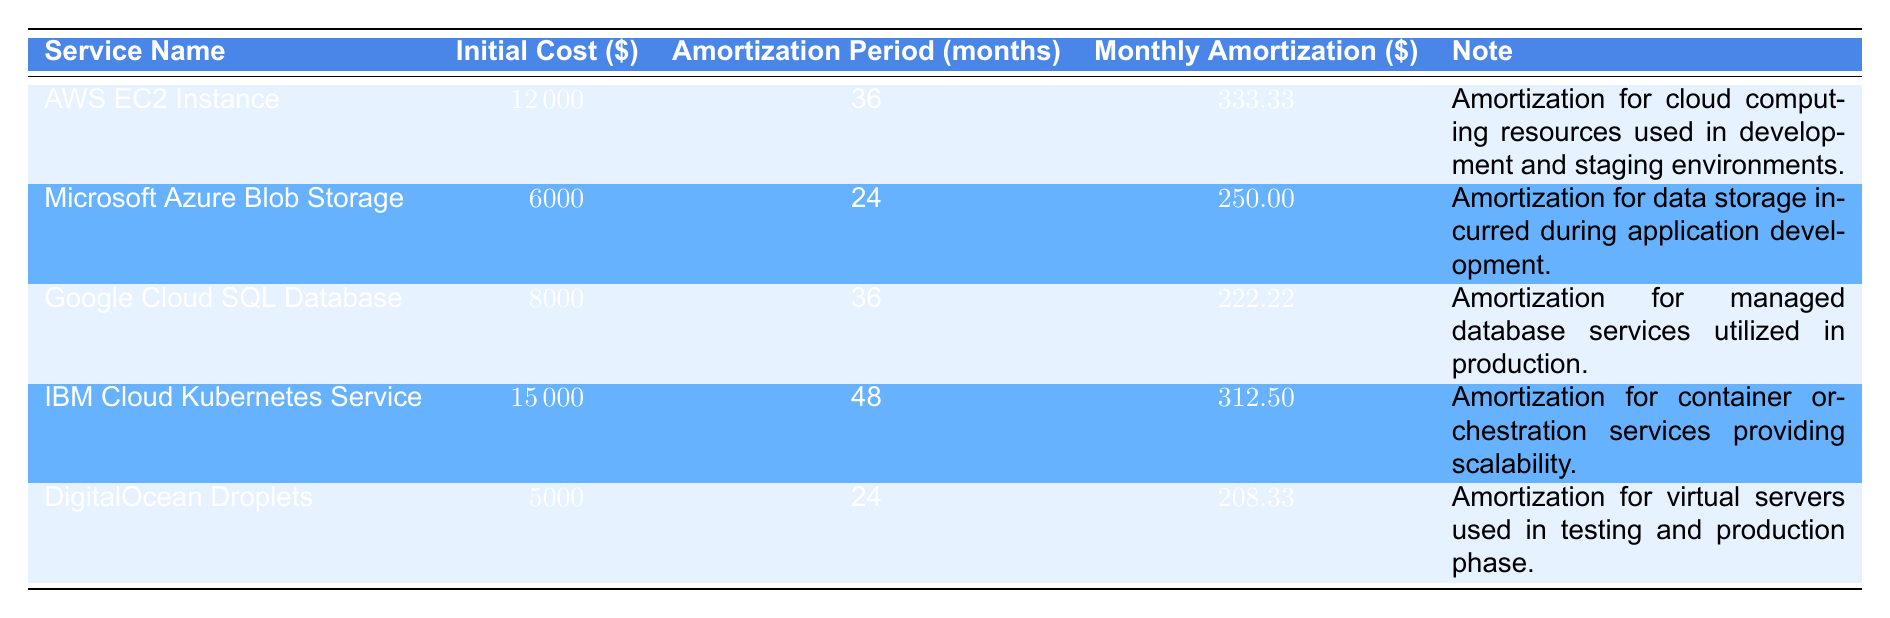What is the initial cost of the AWS EC2 Instance? The initial cost for the AWS EC2 Instance is listed directly in the table under the "Initial Cost" column. It shows a value of 12000.
Answer: 12000 How long is the amortization period for Microsoft Azure Blob Storage? The table specifies the amortization period for Microsoft Azure Blob Storage under "Amortization Period (months)", which is 24 months.
Answer: 24 What is the total initial cost of all the services? To find the total initial cost, we sum the initial costs of all services: 12000 + 6000 + 8000 + 15000 + 5000 = 40000.
Answer: 40000 What is the average monthly amortization of the cloud services? First, we find the total monthly amortization by adding up each service's monthly amortization: 333.33 + 250 + 222.22 + 312.50 + 208.33 = 1326.38. Then we divide by the number of services (5) to get the average: 1326.38 / 5 = 265.28.
Answer: 265.28 Is the total monthly amortization for IBM Cloud Kubernetes Service greater than that of AWS EC2 Instance? The monthly amortization for IBM Cloud Kubernetes Service is 312.50, and for AWS EC2 Instance, it is 333.33. Since 312.50 is less than 333.33, the statement is false.
Answer: No Which service has the longest amortization period? By comparing the "Amortization Period (months)" for all services, we see that IBM Cloud Kubernetes Service has 48 months, which is longer than all others.
Answer: IBM Cloud Kubernetes Service What is the difference in monthly amortization between DigitalOcean Droplets and Google Cloud SQL Database? The monthly amortization for DigitalOcean Droplets is 208.33, and for Google Cloud SQL Database, it is 222.22. The difference is 222.22 - 208.33 = 13.89.
Answer: 13.89 Does the service with the lowest initial cost (DigitalOcean Droplets) have the shortest amortization period? DigitalOcean Droplets has an initial cost of 5000 with an amortization period of 24 months, which is indeed the shortest amortization period compared to the others. Thus, the statement is true.
Answer: Yes How much more does IBM Cloud Kubernetes Service cost initially than Microsoft Azure Blob Storage? The initial cost of IBM Cloud Kubernetes Service is 15000, and for Microsoft Azure Blob Storage, it is 6000. The difference is 15000 - 6000 = 9000.
Answer: 9000 